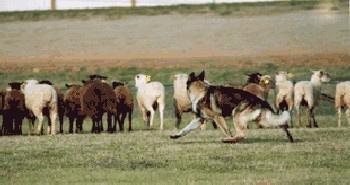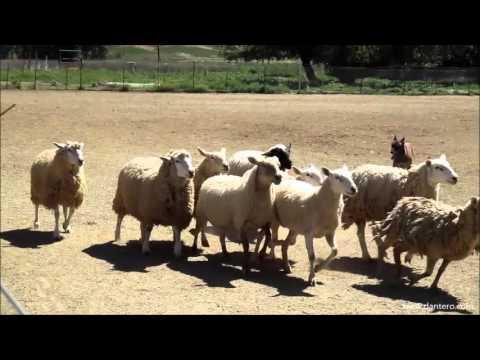The first image is the image on the left, the second image is the image on the right. Evaluate the accuracy of this statement regarding the images: "There are no more than two animals in the image on the right.". Is it true? Answer yes or no. No. 